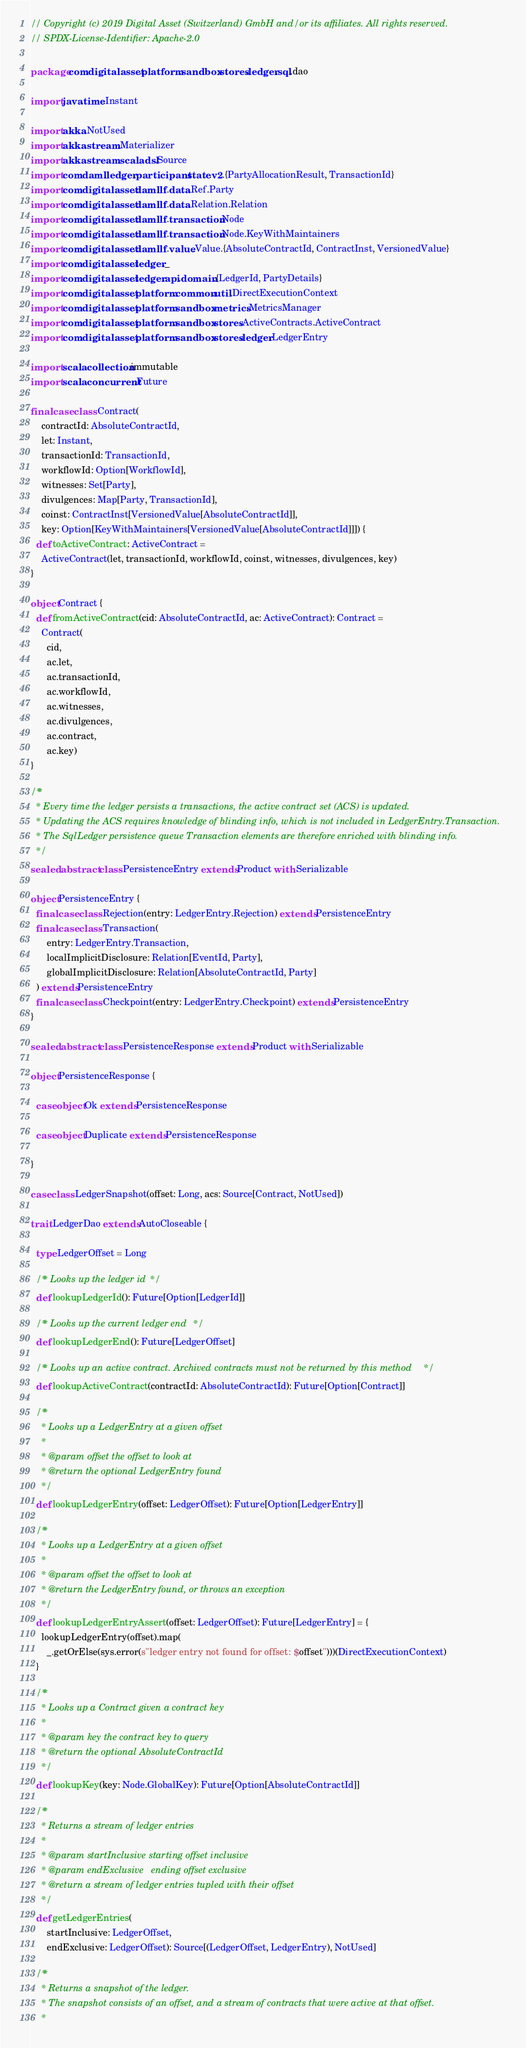<code> <loc_0><loc_0><loc_500><loc_500><_Scala_>// Copyright (c) 2019 Digital Asset (Switzerland) GmbH and/or its affiliates. All rights reserved.
// SPDX-License-Identifier: Apache-2.0

package com.digitalasset.platform.sandbox.stores.ledger.sql.dao

import java.time.Instant

import akka.NotUsed
import akka.stream.Materializer
import akka.stream.scaladsl.Source
import com.daml.ledger.participant.state.v2.{PartyAllocationResult, TransactionId}
import com.digitalasset.daml.lf.data.Ref.Party
import com.digitalasset.daml.lf.data.Relation.Relation
import com.digitalasset.daml.lf.transaction.Node
import com.digitalasset.daml.lf.transaction.Node.KeyWithMaintainers
import com.digitalasset.daml.lf.value.Value.{AbsoluteContractId, ContractInst, VersionedValue}
import com.digitalasset.ledger._
import com.digitalasset.ledger.api.domain.{LedgerId, PartyDetails}
import com.digitalasset.platform.common.util.DirectExecutionContext
import com.digitalasset.platform.sandbox.metrics.MetricsManager
import com.digitalasset.platform.sandbox.stores.ActiveContracts.ActiveContract
import com.digitalasset.platform.sandbox.stores.ledger.LedgerEntry

import scala.collection.immutable
import scala.concurrent.Future

final case class Contract(
    contractId: AbsoluteContractId,
    let: Instant,
    transactionId: TransactionId,
    workflowId: Option[WorkflowId],
    witnesses: Set[Party],
    divulgences: Map[Party, TransactionId],
    coinst: ContractInst[VersionedValue[AbsoluteContractId]],
    key: Option[KeyWithMaintainers[VersionedValue[AbsoluteContractId]]]) {
  def toActiveContract: ActiveContract =
    ActiveContract(let, transactionId, workflowId, coinst, witnesses, divulgences, key)
}

object Contract {
  def fromActiveContract(cid: AbsoluteContractId, ac: ActiveContract): Contract =
    Contract(
      cid,
      ac.let,
      ac.transactionId,
      ac.workflowId,
      ac.witnesses,
      ac.divulgences,
      ac.contract,
      ac.key)
}

/**
  * Every time the ledger persists a transactions, the active contract set (ACS) is updated.
  * Updating the ACS requires knowledge of blinding info, which is not included in LedgerEntry.Transaction.
  * The SqlLedger persistence queue Transaction elements are therefore enriched with blinding info.
  */
sealed abstract class PersistenceEntry extends Product with Serializable

object PersistenceEntry {
  final case class Rejection(entry: LedgerEntry.Rejection) extends PersistenceEntry
  final case class Transaction(
      entry: LedgerEntry.Transaction,
      localImplicitDisclosure: Relation[EventId, Party],
      globalImplicitDisclosure: Relation[AbsoluteContractId, Party]
  ) extends PersistenceEntry
  final case class Checkpoint(entry: LedgerEntry.Checkpoint) extends PersistenceEntry
}

sealed abstract class PersistenceResponse extends Product with Serializable

object PersistenceResponse {

  case object Ok extends PersistenceResponse

  case object Duplicate extends PersistenceResponse

}

case class LedgerSnapshot(offset: Long, acs: Source[Contract, NotUsed])

trait LedgerDao extends AutoCloseable {

  type LedgerOffset = Long

  /** Looks up the ledger id */
  def lookupLedgerId(): Future[Option[LedgerId]]

  /** Looks up the current ledger end */
  def lookupLedgerEnd(): Future[LedgerOffset]

  /** Looks up an active contract. Archived contracts must not be returned by this method */
  def lookupActiveContract(contractId: AbsoluteContractId): Future[Option[Contract]]

  /**
    * Looks up a LedgerEntry at a given offset
    *
    * @param offset the offset to look at
    * @return the optional LedgerEntry found
    */
  def lookupLedgerEntry(offset: LedgerOffset): Future[Option[LedgerEntry]]

  /**
    * Looks up a LedgerEntry at a given offset
    *
    * @param offset the offset to look at
    * @return the LedgerEntry found, or throws an exception
    */
  def lookupLedgerEntryAssert(offset: LedgerOffset): Future[LedgerEntry] = {
    lookupLedgerEntry(offset).map(
      _.getOrElse(sys.error(s"ledger entry not found for offset: $offset")))(DirectExecutionContext)
  }

  /**
    * Looks up a Contract given a contract key
    *
    * @param key the contract key to query
    * @return the optional AbsoluteContractId
    */
  def lookupKey(key: Node.GlobalKey): Future[Option[AbsoluteContractId]]

  /**
    * Returns a stream of ledger entries
    *
    * @param startInclusive starting offset inclusive
    * @param endExclusive   ending offset exclusive
    * @return a stream of ledger entries tupled with their offset
    */
  def getLedgerEntries(
      startInclusive: LedgerOffset,
      endExclusive: LedgerOffset): Source[(LedgerOffset, LedgerEntry), NotUsed]

  /**
    * Returns a snapshot of the ledger.
    * The snapshot consists of an offset, and a stream of contracts that were active at that offset.
    *</code> 